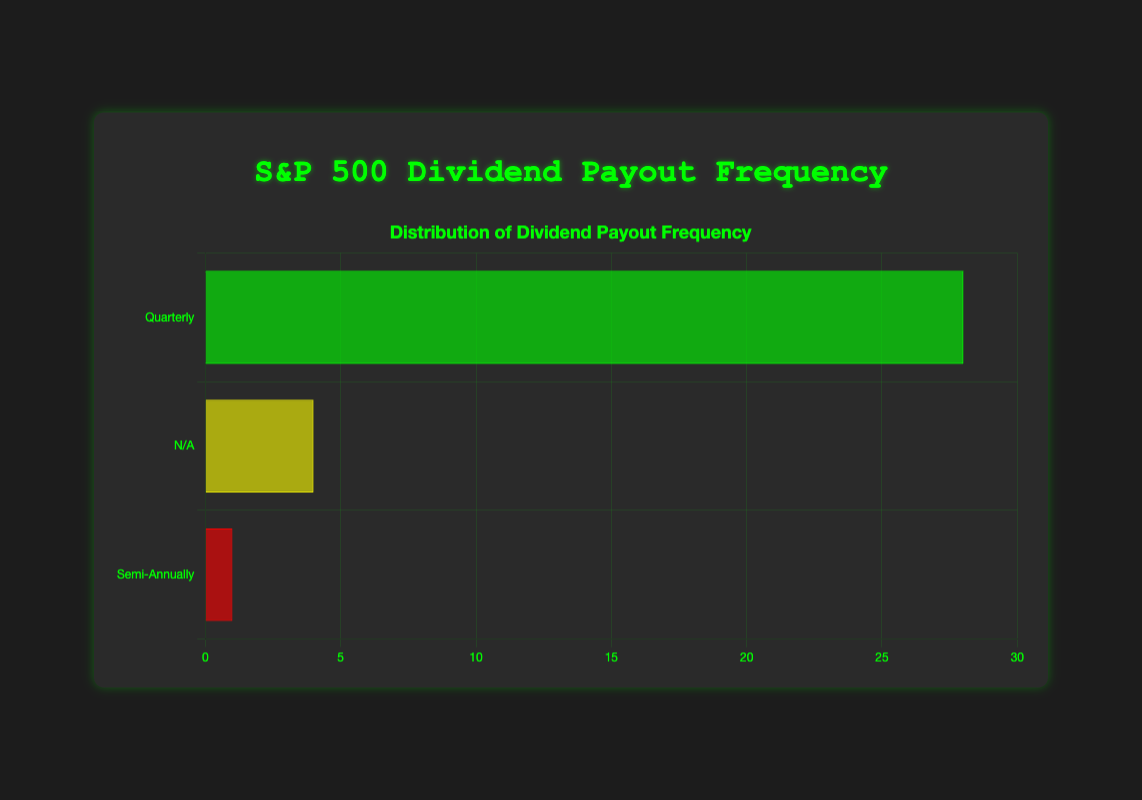Which dividend payout frequency category has the highest number of companies? By looking at the heights of the bars on the horizontal bar chart, we can see that the 'Quarterly' category has the highest bar, indicating that it has the most number of companies.
Answer: Quarterly How many companies do not have a dividend payout frequency? By examining the chart, we observe the 'N/A' bar. The length of this bar represents the number of companies that do not have a dividend payout frequency.
Answer: 4 What is the difference between the number of companies paying dividends quarterly and those not paying dividends? The 'Quarterly' bar is significantly longer than the 'N/A' bar. To find the difference, we subtract the number of 'N/A' companies from 'Quarterly' companies (28 - 4).
Answer: 24 Which dividend payout frequency categories are represented by only one company? We look for the smallest bars on the chart. The 'Semi-Annually' category has only one company.
Answer: Semi-Annually What is the total number of companies displayed in the chart? Adding up the numbers from all the bars: Total = 28 (Quarterly) + 4 (N/A) + 1 (Semi-Annually). This accounts for the sum of companies across all categories.
Answer: 33 Compare the number of companies paying dividends semi-annually and those not paying dividends at all. The length of the 'N/A' bar is longer than the 'Semi-Annually' bar. Specifically, 'N/A' has 4 companies while 'Semi-Annually' has only 1.
Answer: N/A What fraction of the total companies pay dividends quarterly? First, identify the total number of companies (33). Then divide the number of companies that pay quarterly (28) by the total. So, the fraction is 28/33.
Answer: 28/33 Which category has the shortest bar and how many companies does it represent? The shortest bar is the 'Semi-Annually' category. By observing the length, it represents only 1 company.
Answer: Semi-Annually, 1 Estimate the percentage of companies that pay dividends quarterly. Using the number of companies that pay quarterly (28) and the total number (33), calculate the percentage: (28/33) * 100 ≈ 84.85%.
Answer: Approximately 84.85% 